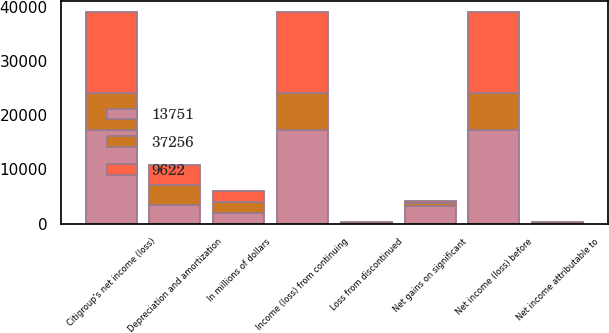<chart> <loc_0><loc_0><loc_500><loc_500><stacked_bar_chart><ecel><fcel>In millions of dollars<fcel>Net income (loss) before<fcel>Net income attributable to<fcel>Citigroup's net income (loss)<fcel>Loss from discontinued<fcel>Income (loss) from continuing<fcel>Net gains on significant<fcel>Depreciation and amortization<nl><fcel>37256<fcel>2017<fcel>6738<fcel>60<fcel>6798<fcel>111<fcel>6687<fcel>602<fcel>3659<nl><fcel>9622<fcel>2016<fcel>14975<fcel>63<fcel>14912<fcel>58<fcel>14970<fcel>404<fcel>3720<nl><fcel>13751<fcel>2015<fcel>17332<fcel>90<fcel>17242<fcel>54<fcel>17296<fcel>3210<fcel>3506<nl></chart> 